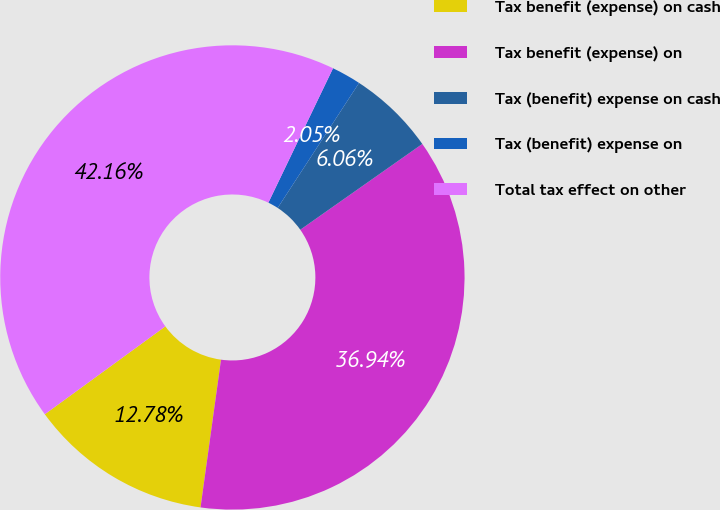Convert chart. <chart><loc_0><loc_0><loc_500><loc_500><pie_chart><fcel>Tax benefit (expense) on cash<fcel>Tax benefit (expense) on<fcel>Tax (benefit) expense on cash<fcel>Tax (benefit) expense on<fcel>Total tax effect on other<nl><fcel>12.78%<fcel>36.94%<fcel>6.06%<fcel>2.05%<fcel>42.16%<nl></chart> 